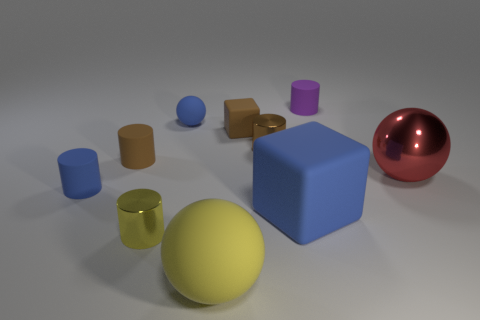What color is the other ball that is made of the same material as the yellow ball?
Your answer should be compact. Blue. Are there fewer tiny brown rubber objects than spheres?
Your response must be concise. Yes. The blue thing that is in front of the big red sphere and left of the blue cube is made of what material?
Provide a short and direct response. Rubber. There is a small brown matte thing on the right side of the small yellow cylinder; is there a blue matte thing in front of it?
Your answer should be compact. Yes. How many rubber things have the same color as the tiny rubber ball?
Offer a terse response. 2. What is the material of the cylinder that is the same color as the small ball?
Provide a succinct answer. Rubber. Do the tiny block and the yellow cylinder have the same material?
Offer a very short reply. No. Are there any rubber cylinders left of the small blue rubber sphere?
Your answer should be compact. Yes. There is a blue cylinder that is left of the ball on the right side of the small purple rubber thing; what is it made of?
Your response must be concise. Rubber. There is a blue matte thing that is the same shape as the big metallic thing; what is its size?
Your answer should be compact. Small. 